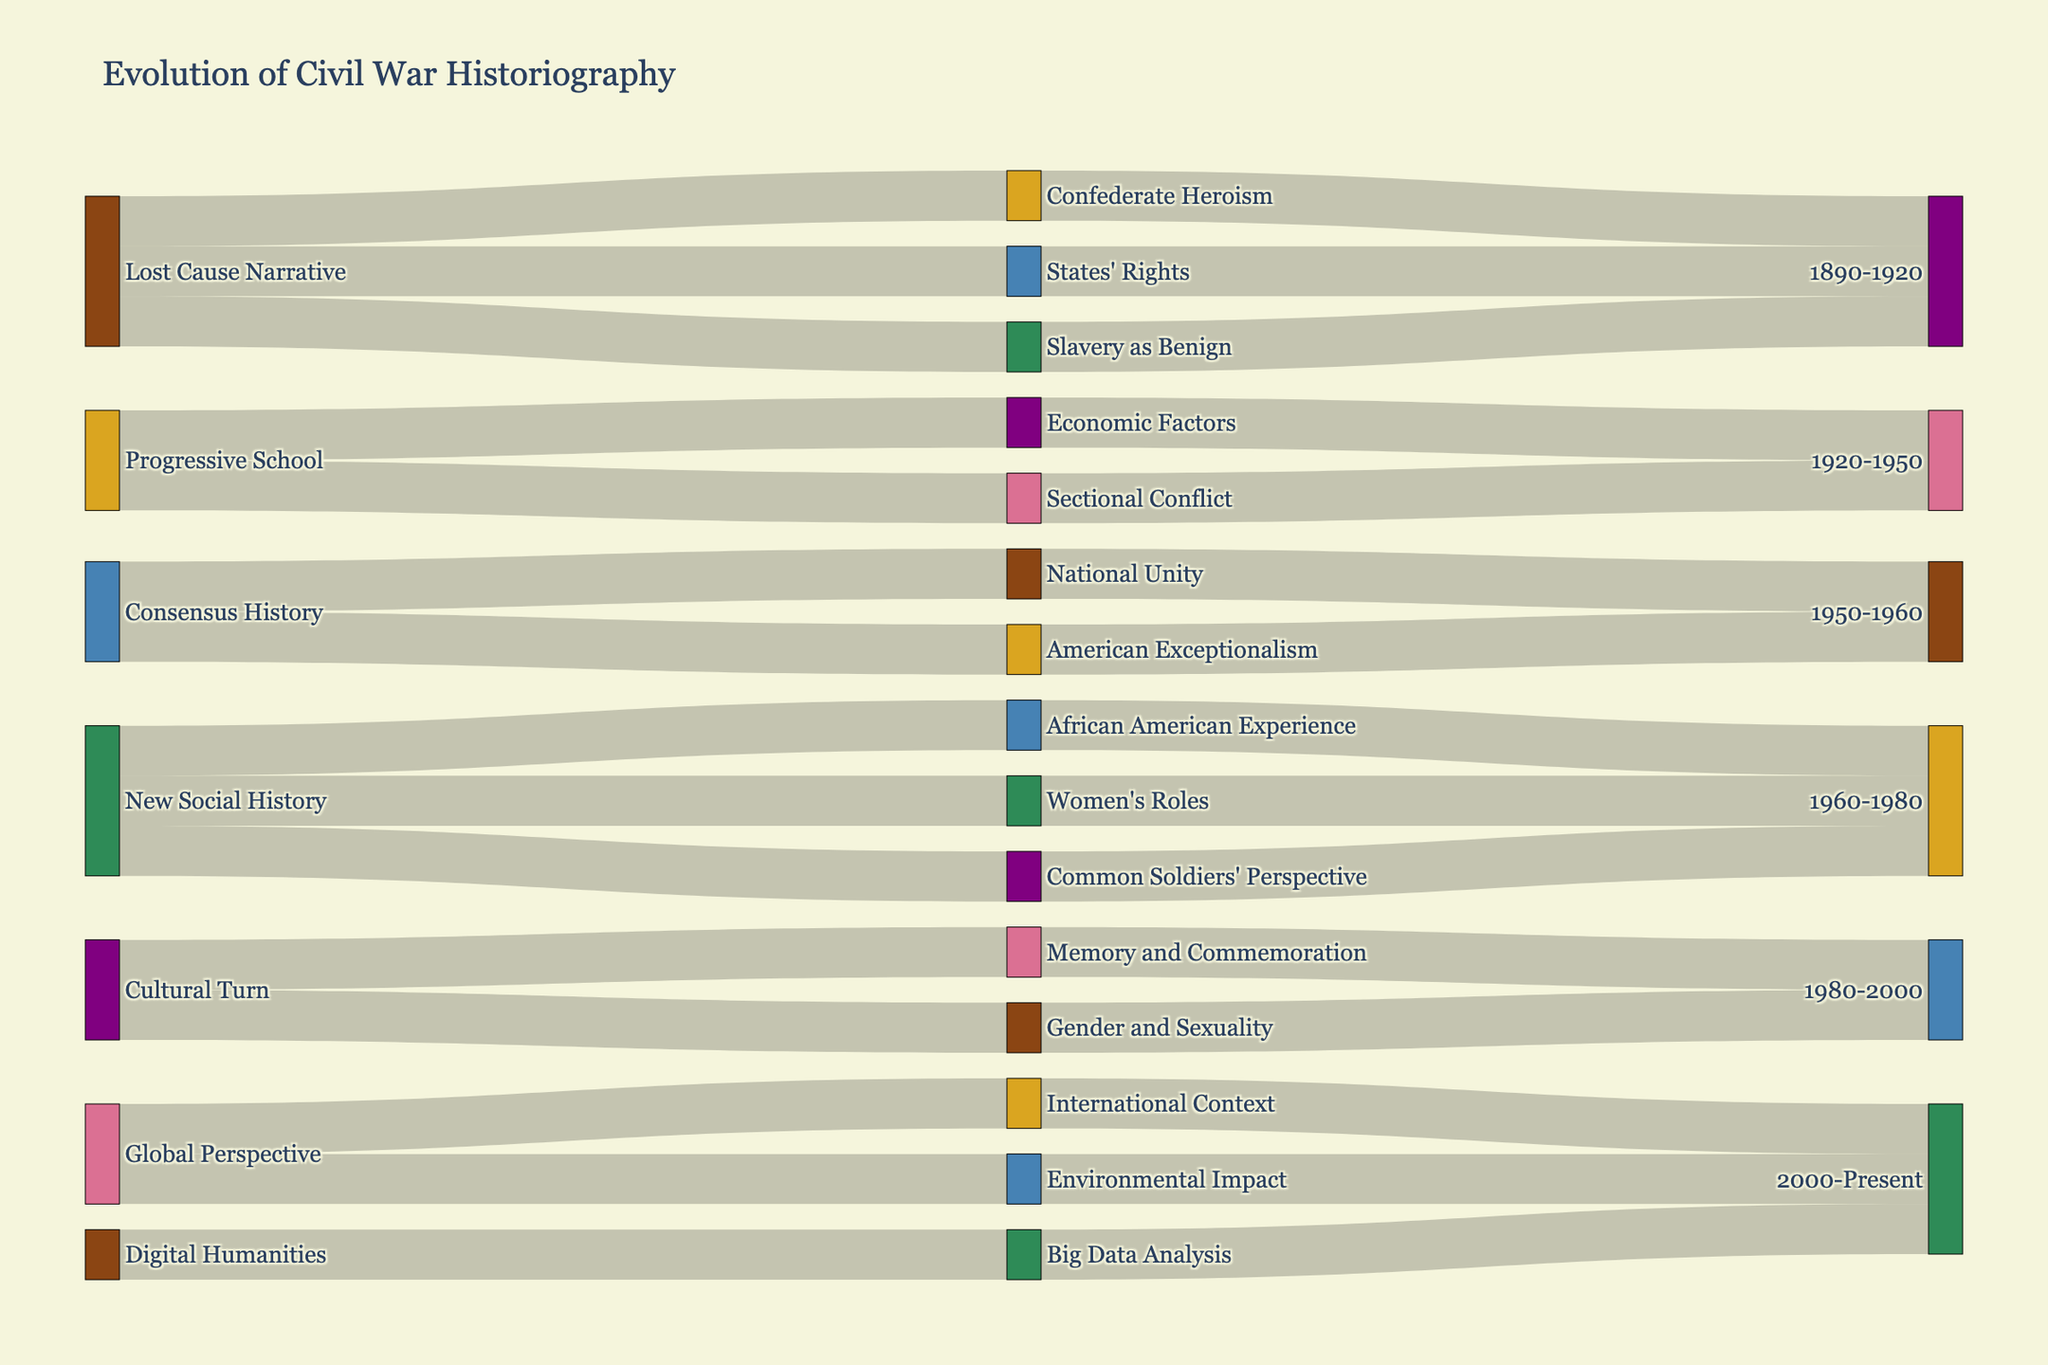What is the title of the Sankey diagram? The title is displayed at the top of the Sankey diagram in a larger font than other texts, clearly indicating the subject of the diagram. In this case, it is about the progression of how the Civil War has been documented and interpreted over time.
Answer: Evolution of Civil War Historiography What are the sources of interpretation identified between 1890-1920? Break down the diagram starting from the 'Lost Cause Narrative' source node and observe its connections leading to the interpretations within the era 1890-1920.
Answer: Confederate Heroism, States' Rights, Slavery as Benign How many eras are present in the Sankey diagram? Count the nodes that represent different eras. Each era node will contain a time range, making it easier to identify them in the diagram.
Answer: 5 Which era follows the Progressive School in historical interpretations? Follow the flow from the node labeled 'Progressive School' and identify the era that comes immediately after it within the diagram.
Answer: 1920-1950 What interpretation is linked to both 'Lost Cause Narrative' and 'Cultural Turn'? Trace the connections from both 'Lost Cause Narrative' and 'Cultural Turn' toward their respective interpretation nodes and identify any common interpretation between them.
Answer: None Circle out all interpretations listed for era 1960-1980. Look specifically at the Sankey flow leading to the era node labeled '1960-1980' and identify all the interpretation nodes connected to it.
Answer: African American Experience, Women's Roles, Common Soldiers' Perspective Which interpretation has evolved from 'Progressive School' to be associated with 'New Social History'? Identify the interpretations for 'Progressive School' and see which of them appear again under the 'New Social History' section. Observe the connections in the Sankey diagram between these entities.
Answer: Sectional Conflict How many unique interpretations have occurred according to the diagram? Count each unique interpretation node once within the diagram. Each different label stands as a unique interpretation.
Answer: 13 Which two eras follow the 'Cultural Turn'? Track the connections leading from the 'Cultural Turn' node to the subsequent era nodes according to the flow of the diagram.
Answer: 2000-Present What are the interpretations associated with the 'Global Perspective' era? Follow the flows arriving at the '2000-Present' era node, particularly focusing on those leading from interpretations associated under the 'Global Perspective'.
Answer: International Context, Environmental Impact 